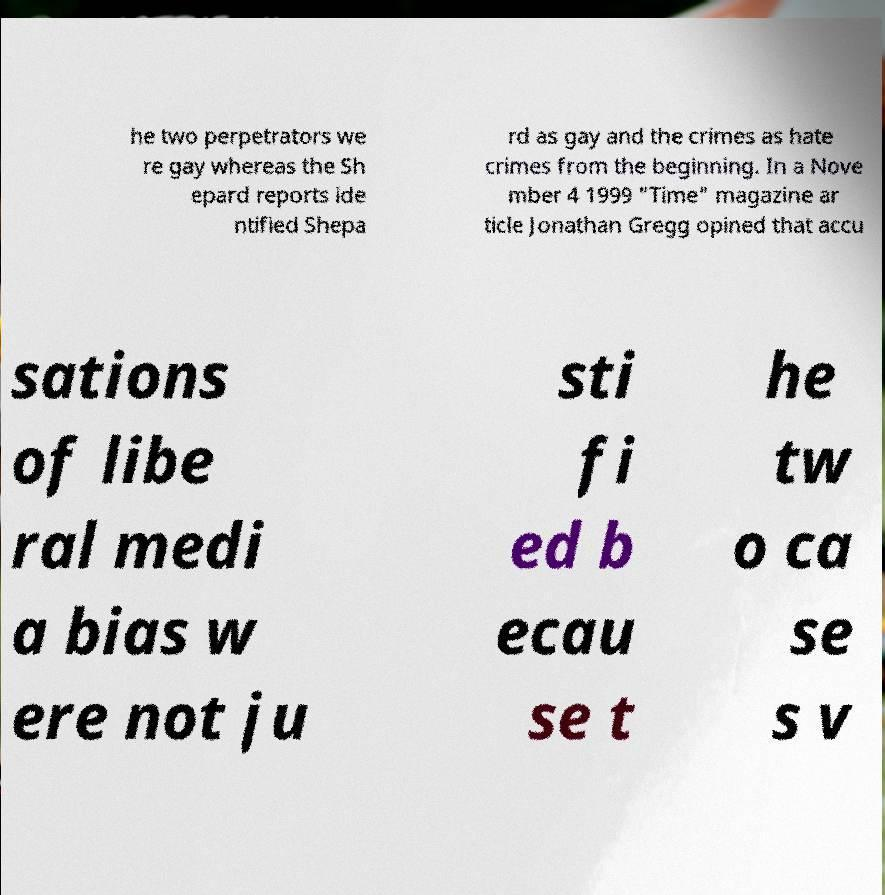Can you accurately transcribe the text from the provided image for me? he two perpetrators we re gay whereas the Sh epard reports ide ntified Shepa rd as gay and the crimes as hate crimes from the beginning. In a Nove mber 4 1999 "Time" magazine ar ticle Jonathan Gregg opined that accu sations of libe ral medi a bias w ere not ju sti fi ed b ecau se t he tw o ca se s v 